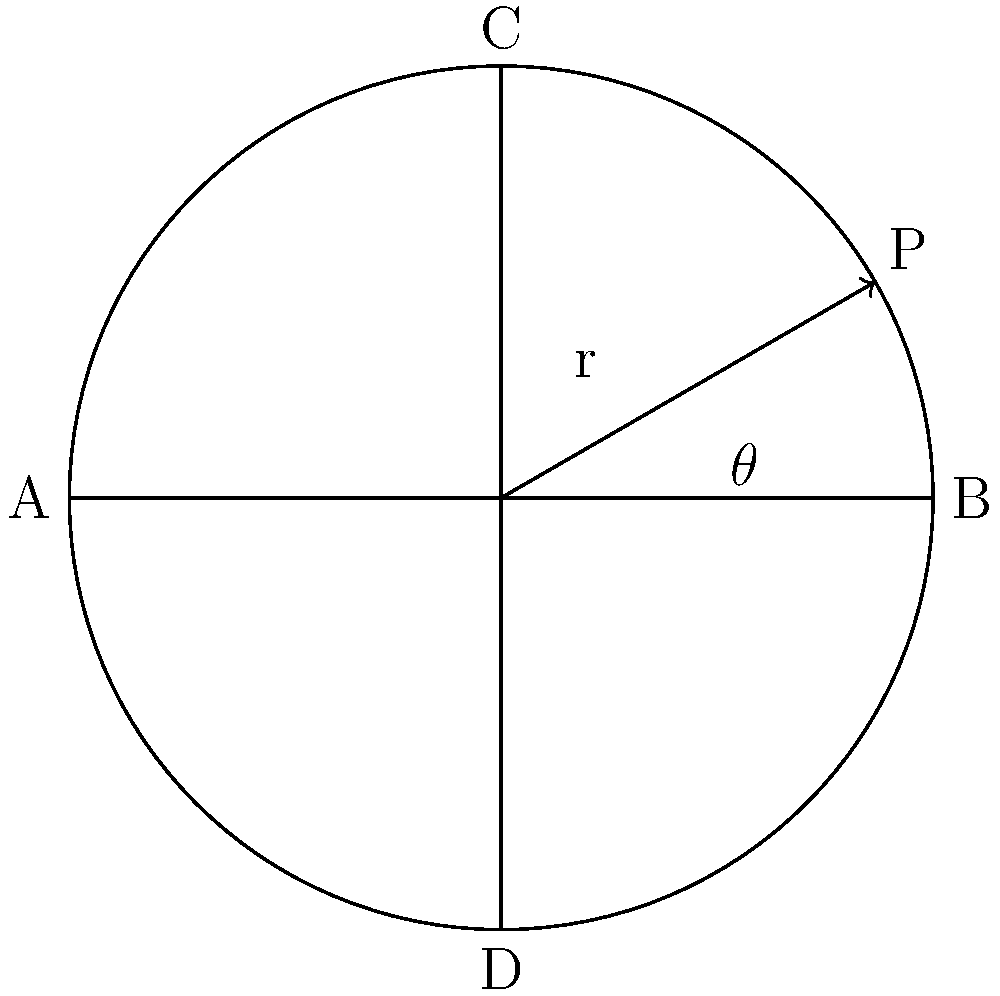In a geodesic dome with a radius of 20 meters, the structural load is distributed along great circles. If a point load P is applied at an angle $\theta = 30°$ from the horizontal, what is the vertical component of the force experienced at point C? Assume the total load is 10,000 N and that the load is distributed inversely proportional to the distance from the application point. To solve this problem, we'll follow these steps:

1) First, we need to find the distance between the load application point (P) and point C.
   The chord length can be calculated using the formula: $d = 2r \sin(\frac{\alpha}{2})$
   Where $r$ is the radius and $\alpha$ is the central angle.

   $\alpha = 90° - 30° = 60°$
   $d = 2 * 20 * \sin(30°) = 20$ meters

2) The vertical component of the force at C will be proportional to $\frac{1}{d}$ and to $\sin(30°)$.

3) We need to find what portion of the total load this represents. The total "inverse distance" is the sum of inverse distances to all points. In a continuous distribution, this would be an integral, but for our purposes, we can approximate it as:

   $\frac{1}{20} + \frac{1}{20} + \frac{1}{20\sqrt{2}} + \frac{1}{20\sqrt{2}} = 0.1414$

4) The portion of the load at C is thus:
   $\frac{\frac{1}{20}}{0.1414} = 0.3536$

5) The vertical component is:
   $F_v = 10,000 * 0.3536 * \sin(30°) = 1,768$ N
Answer: 1,768 N 